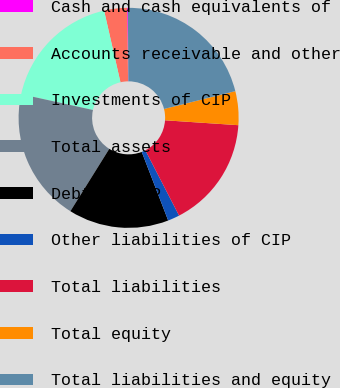Convert chart. <chart><loc_0><loc_0><loc_500><loc_500><pie_chart><fcel>Cash and cash equivalents of<fcel>Accounts receivable and other<fcel>Investments of CIP<fcel>Total assets<fcel>Debt of CIP<fcel>Other liabilities of CIP<fcel>Total liabilities<fcel>Total equity<fcel>Total liabilities and equity<nl><fcel>0.12%<fcel>3.35%<fcel>17.97%<fcel>19.58%<fcel>14.73%<fcel>1.73%<fcel>16.35%<fcel>4.97%<fcel>21.2%<nl></chart> 